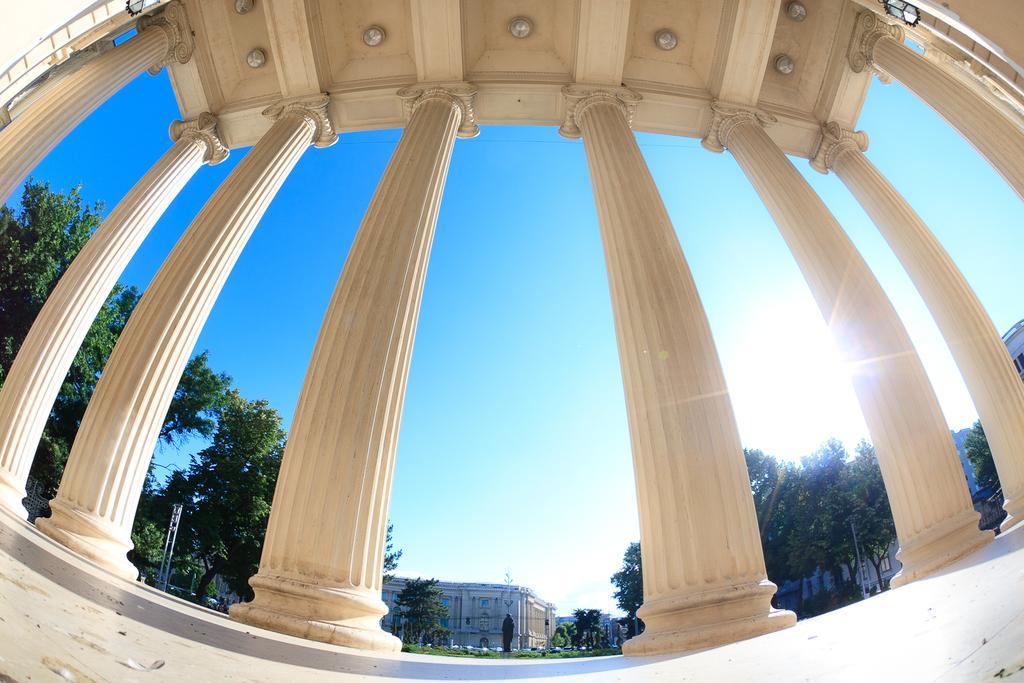Describe this image in one or two sentences. In the image there is a building in the front with many pillars, in the back there are many trees all over the place with building in the background and above its sky with sun on the right side. 